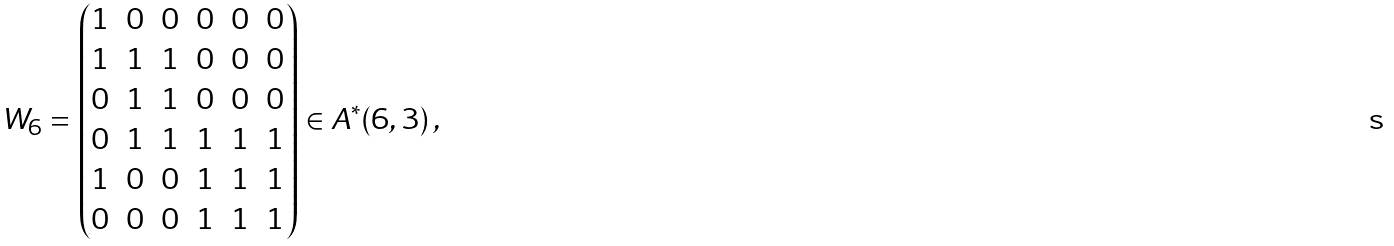<formula> <loc_0><loc_0><loc_500><loc_500>W _ { 6 } = \begin{pmatrix} 1 & 0 & 0 & 0 & 0 & 0 \\ 1 & 1 & 1 & 0 & 0 & 0 \\ 0 & 1 & 1 & 0 & 0 & 0 \\ 0 & 1 & 1 & 1 & 1 & 1 \\ 1 & 0 & 0 & 1 & 1 & 1 \\ 0 & 0 & 0 & 1 & 1 & 1 \end{pmatrix} \in A ^ { * } ( 6 , 3 ) \, ,</formula> 